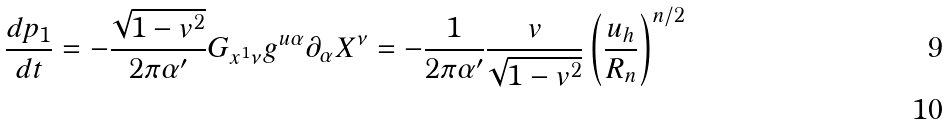Convert formula to latex. <formula><loc_0><loc_0><loc_500><loc_500>\frac { d p _ { 1 } } { d t } = - \frac { \sqrt { 1 - v ^ { 2 } } } { 2 \pi \alpha ^ { \prime } } G _ { x ^ { 1 } \nu } g ^ { u \alpha } \partial _ { \alpha } X ^ { \nu } = - \frac { 1 } { 2 \pi \alpha ^ { \prime } } \frac { v } { \sqrt { 1 - v ^ { 2 } } } \left ( \frac { u _ { h } } { R _ { n } } \right ) ^ { n / 2 } \\</formula> 